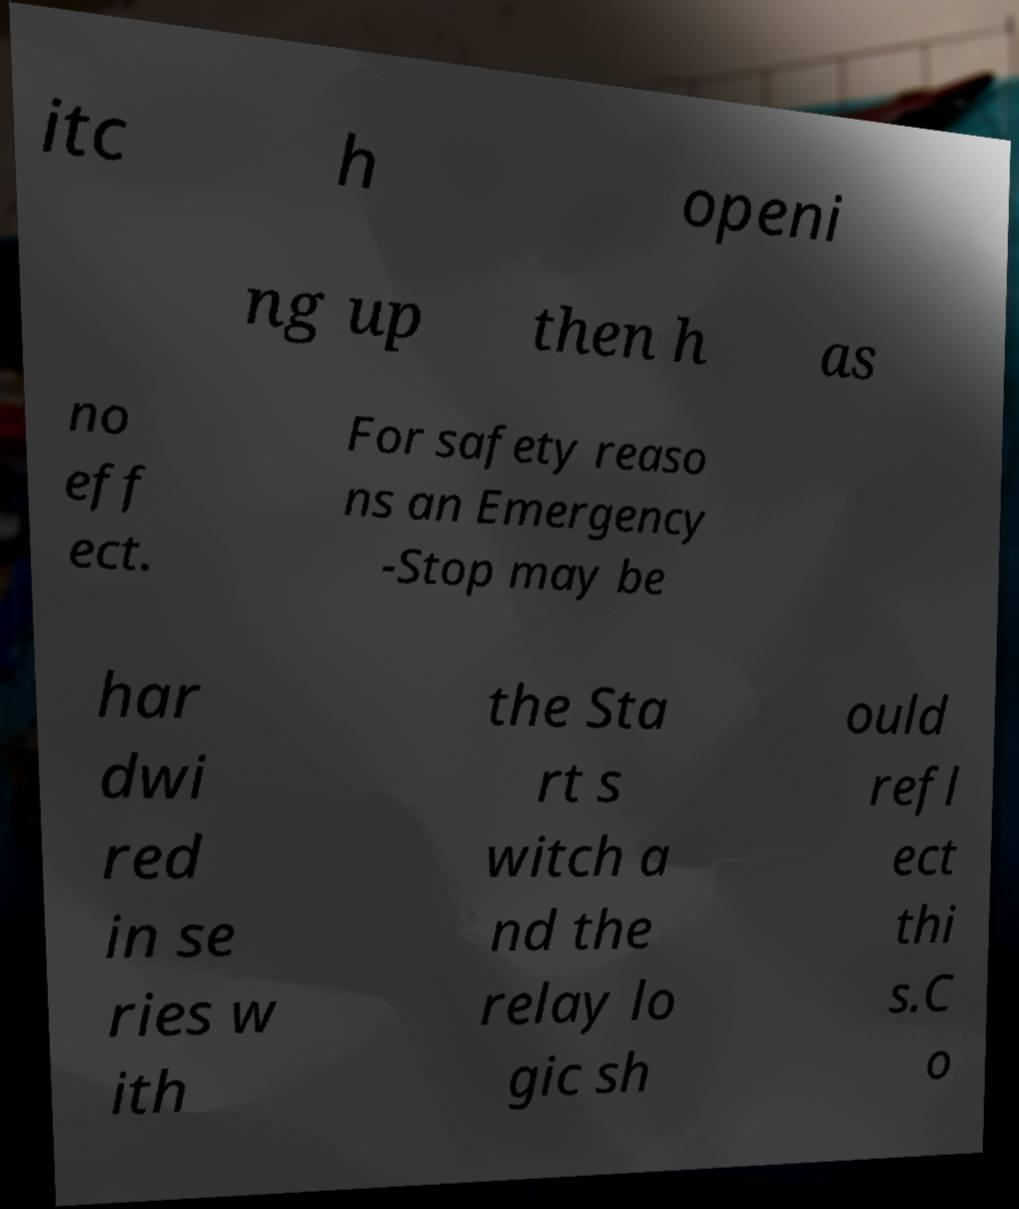Could you assist in decoding the text presented in this image and type it out clearly? itc h openi ng up then h as no eff ect. For safety reaso ns an Emergency -Stop may be har dwi red in se ries w ith the Sta rt s witch a nd the relay lo gic sh ould refl ect thi s.C o 